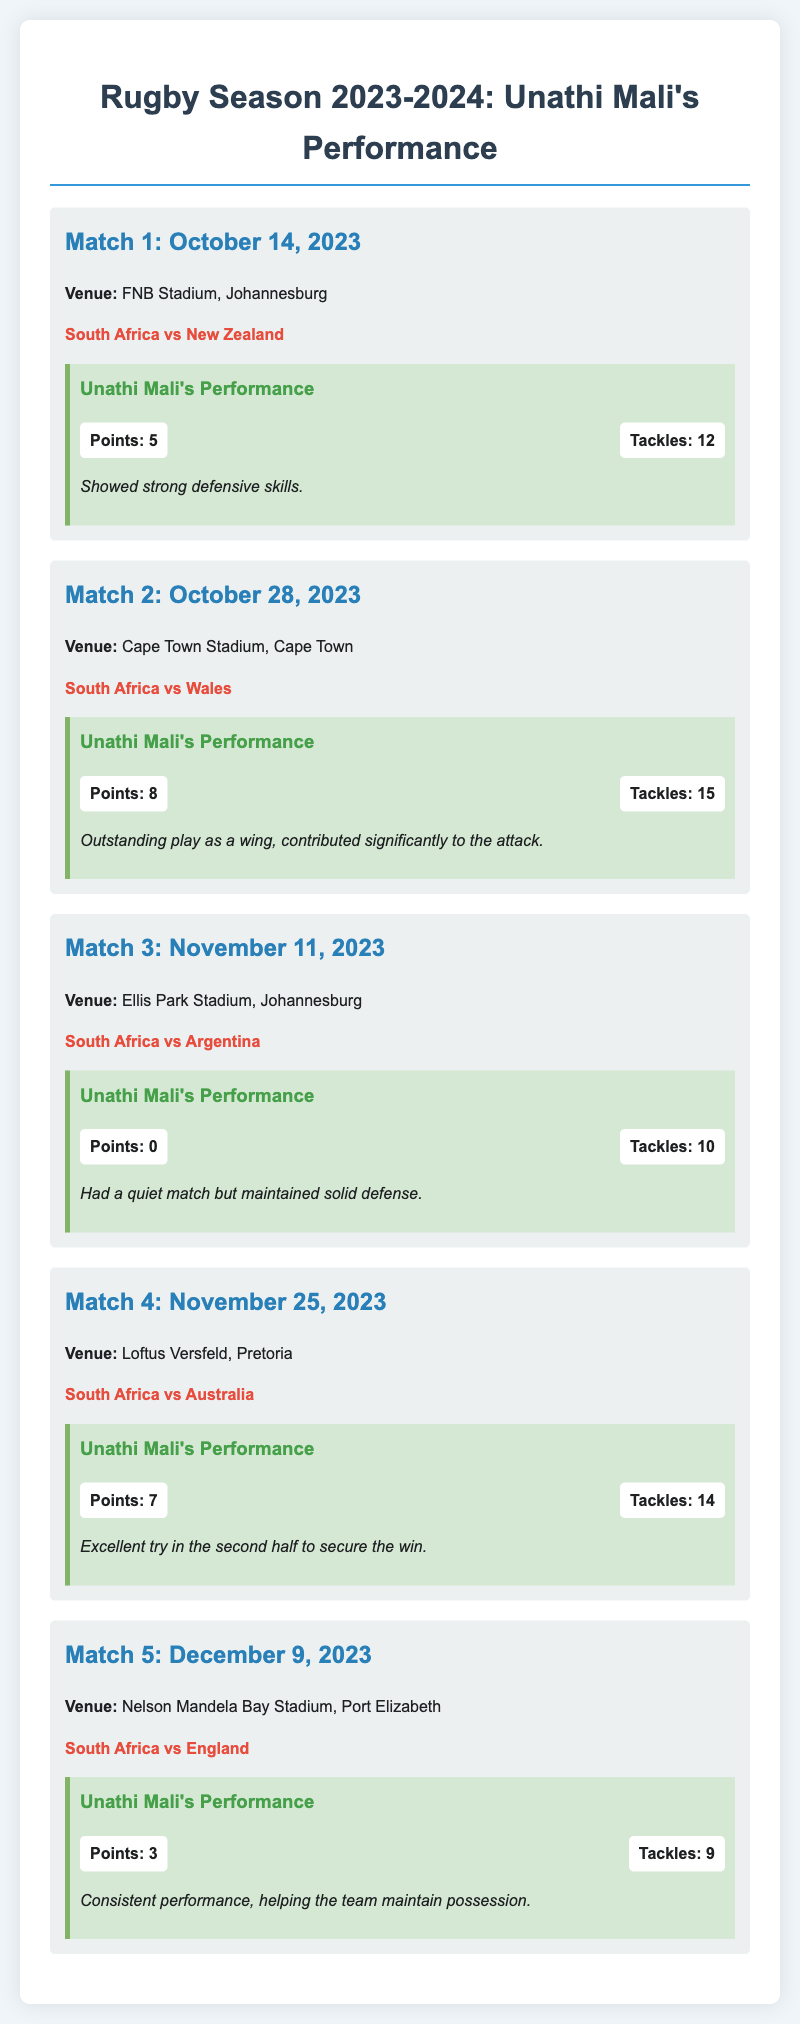What is the date of Match 1? Match 1 is scheduled for October 14, 2023.
Answer: October 14, 2023 Where is Match 2 being held? Match 2 will take place at Cape Town Stadium, Cape Town.
Answer: Cape Town Stadium, Cape Town Who played against South Africa in Match 4? South Africa faced Australia in Match 4.
Answer: Australia How many tackles did Unathi Mali make in Match 3? In Match 3, Unathi Mali made 10 tackles.
Answer: 10 What was Unathi Mali's total points in the season? The total points scored by Unathi Mali can be calculated as 5 + 8 + 0 + 7 + 3 = 23.
Answer: 23 Which match featured Unathi Mali scoring the highest points? Match 2 featured Unathi Mali scoring the highest points with 8.
Answer: Match 2 What performance note is associated with Match 4? It notes that Unathi Mali had an excellent try in the second half to secure the win.
Answer: Excellent try in the second half to secure the win How many matches are listed in the document? There are five matches listed in the document.
Answer: Five matches What venue is used for the final match of the season? The final match is held at Nelson Mandela Bay Stadium, Port Elizabeth.
Answer: Nelson Mandela Bay Stadium, Port Elizabeth 